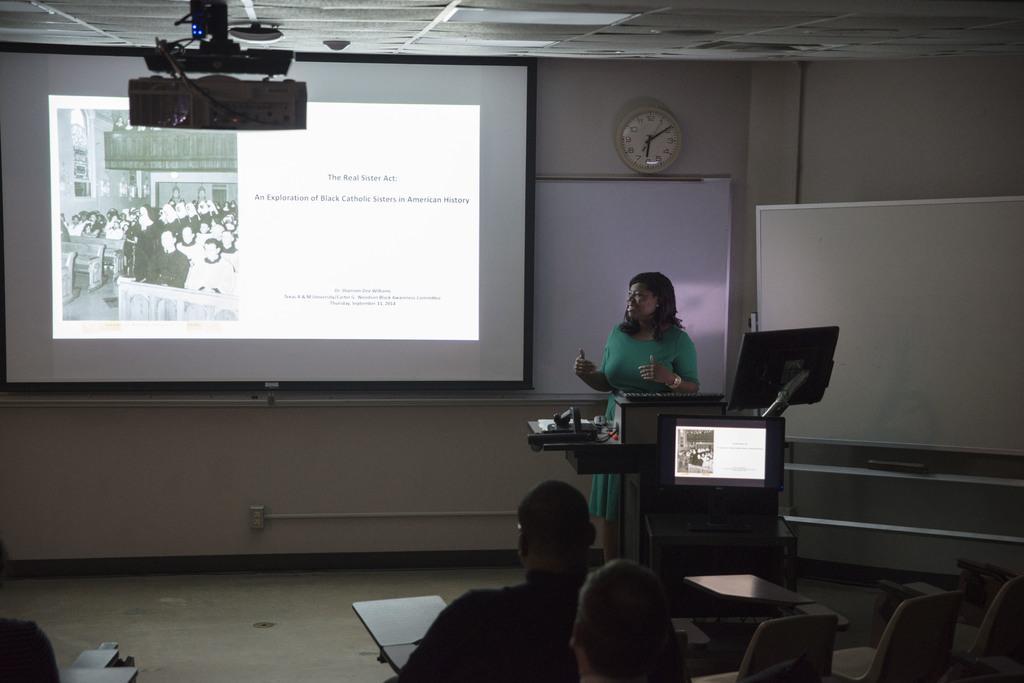Could you give a brief overview of what you see in this image? In this image I can see few persons sitting. In front I can see the person standing and the person is wearing green color dress and I can also see the projection screen and a white color board attached to the wall and I can also see a clock and the wall is in white color. 